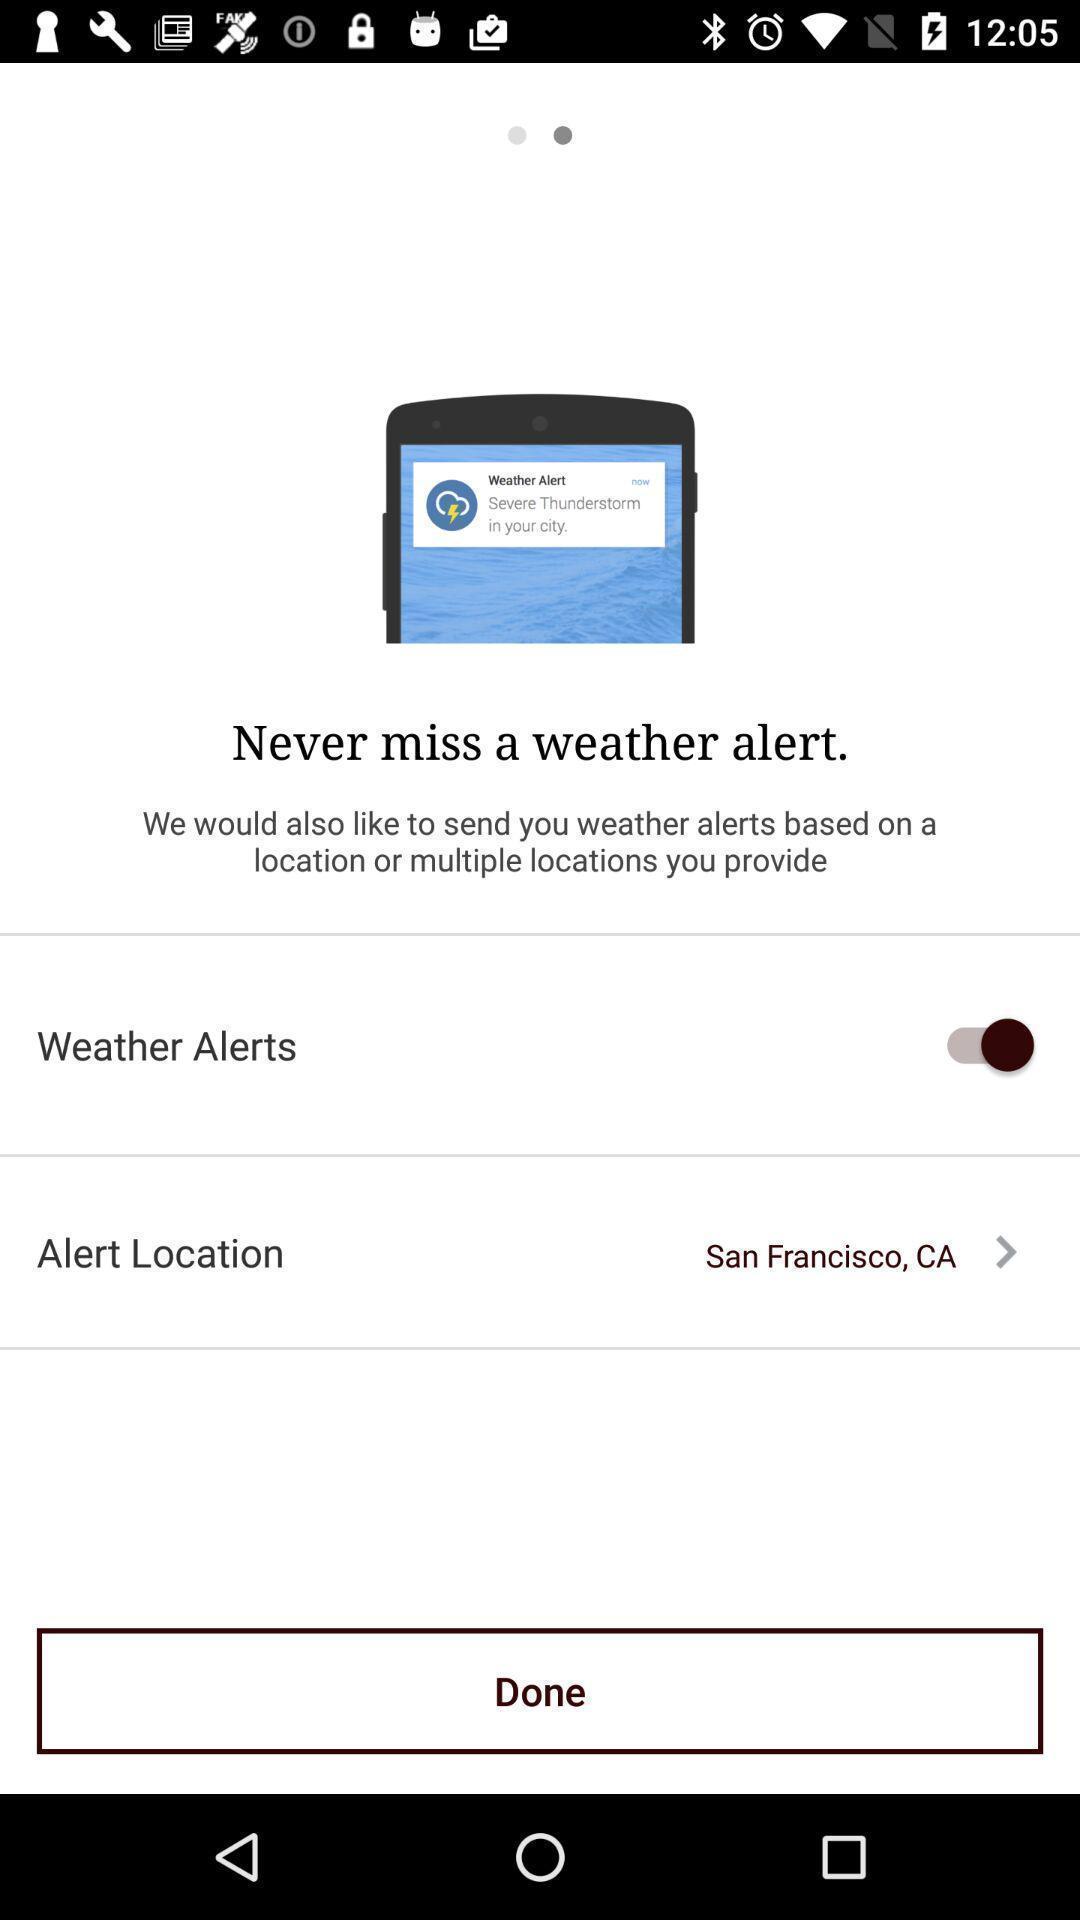Explain the elements present in this screenshot. Screen displaying the weather alert page. 